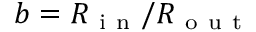<formula> <loc_0><loc_0><loc_500><loc_500>b = R _ { i n } / R _ { o u t }</formula> 